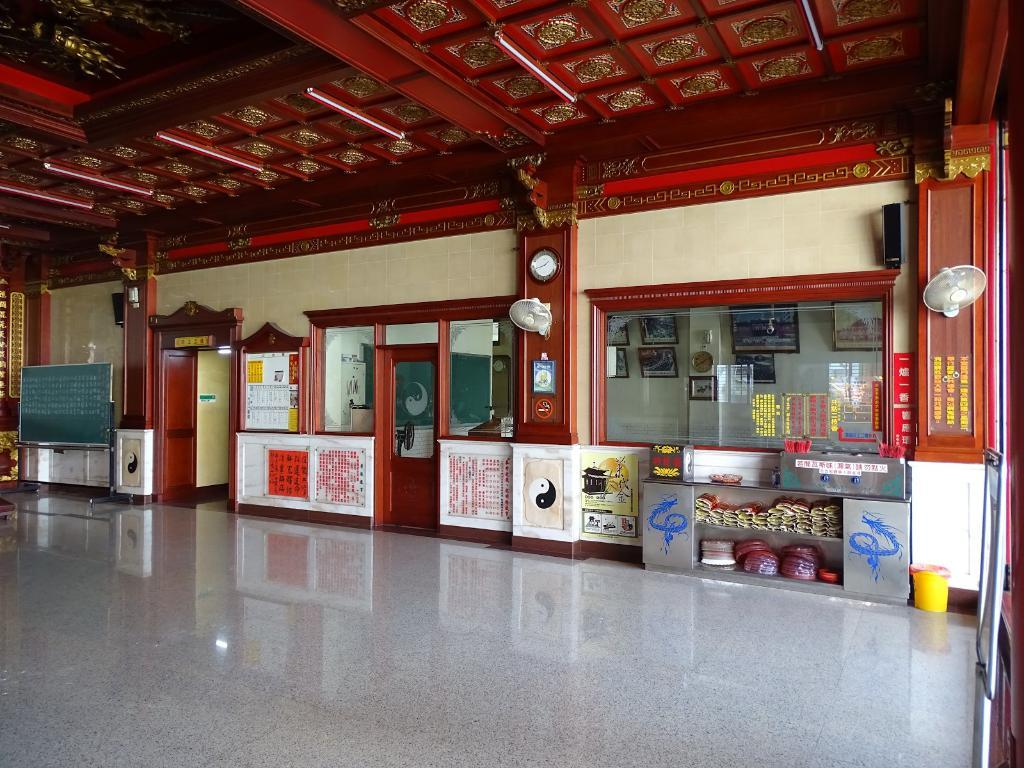Provide a one-sentence caption for the provided image. the inside of a building with a no smoking sign on the wlal. 